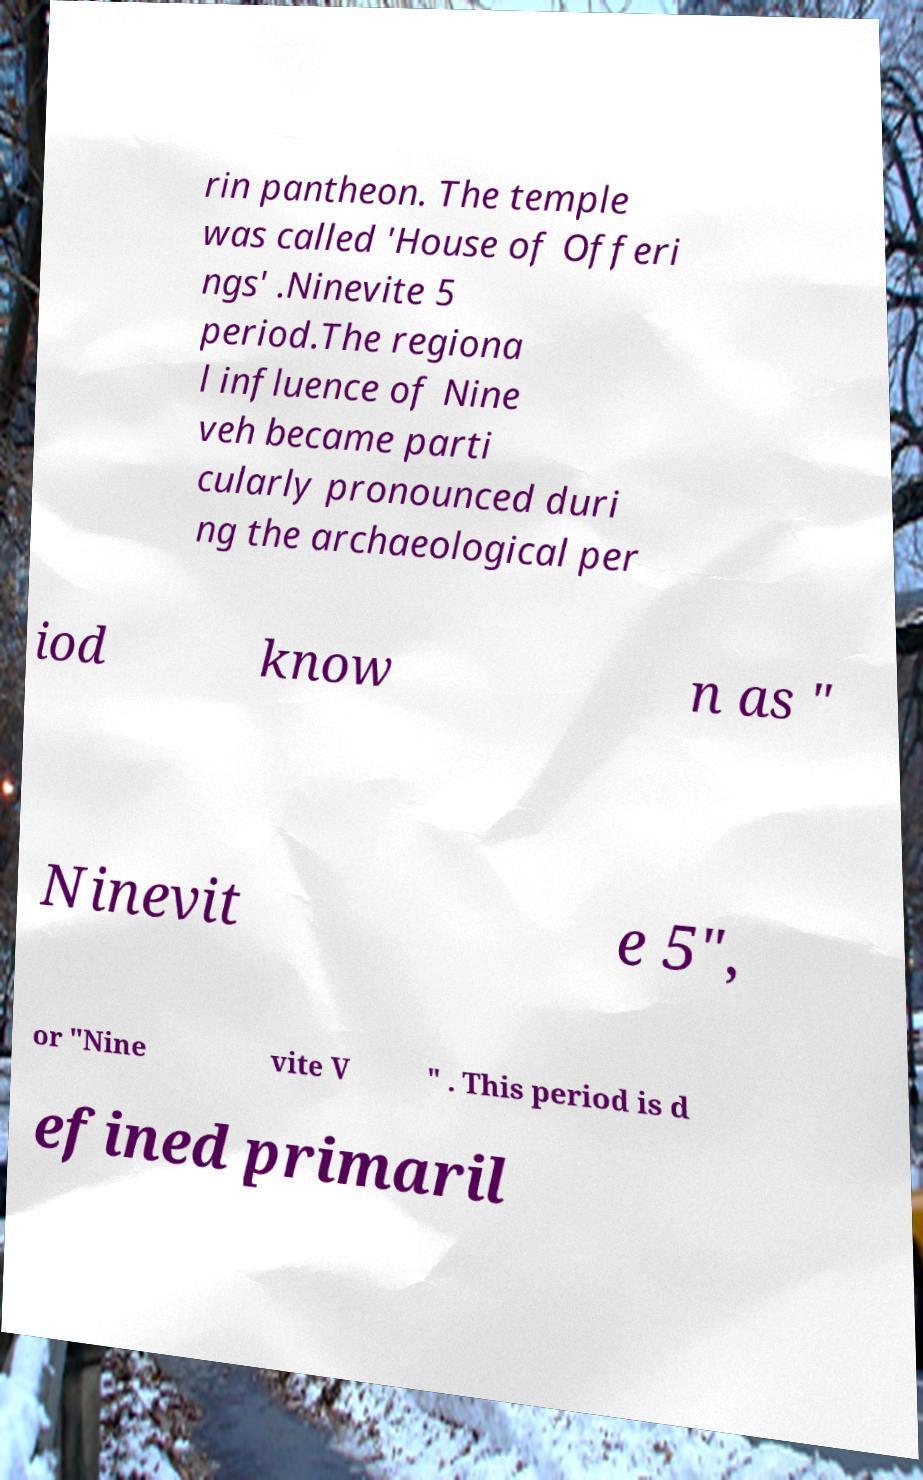Please identify and transcribe the text found in this image. rin pantheon. The temple was called 'House of Offeri ngs' .Ninevite 5 period.The regiona l influence of Nine veh became parti cularly pronounced duri ng the archaeological per iod know n as " Ninevit e 5", or "Nine vite V " . This period is d efined primaril 